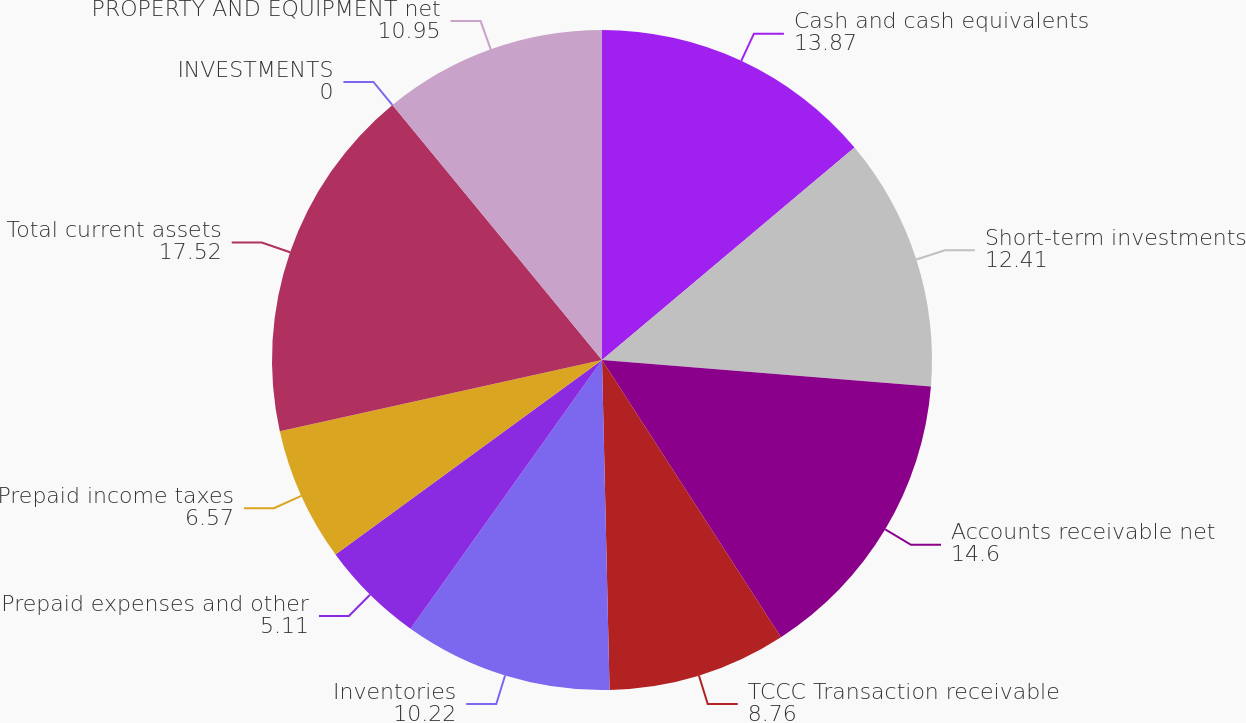<chart> <loc_0><loc_0><loc_500><loc_500><pie_chart><fcel>Cash and cash equivalents<fcel>Short-term investments<fcel>Accounts receivable net<fcel>TCCC Transaction receivable<fcel>Inventories<fcel>Prepaid expenses and other<fcel>Prepaid income taxes<fcel>Total current assets<fcel>INVESTMENTS<fcel>PROPERTY AND EQUIPMENT net<nl><fcel>13.87%<fcel>12.41%<fcel>14.6%<fcel>8.76%<fcel>10.22%<fcel>5.11%<fcel>6.57%<fcel>17.52%<fcel>0.0%<fcel>10.95%<nl></chart> 